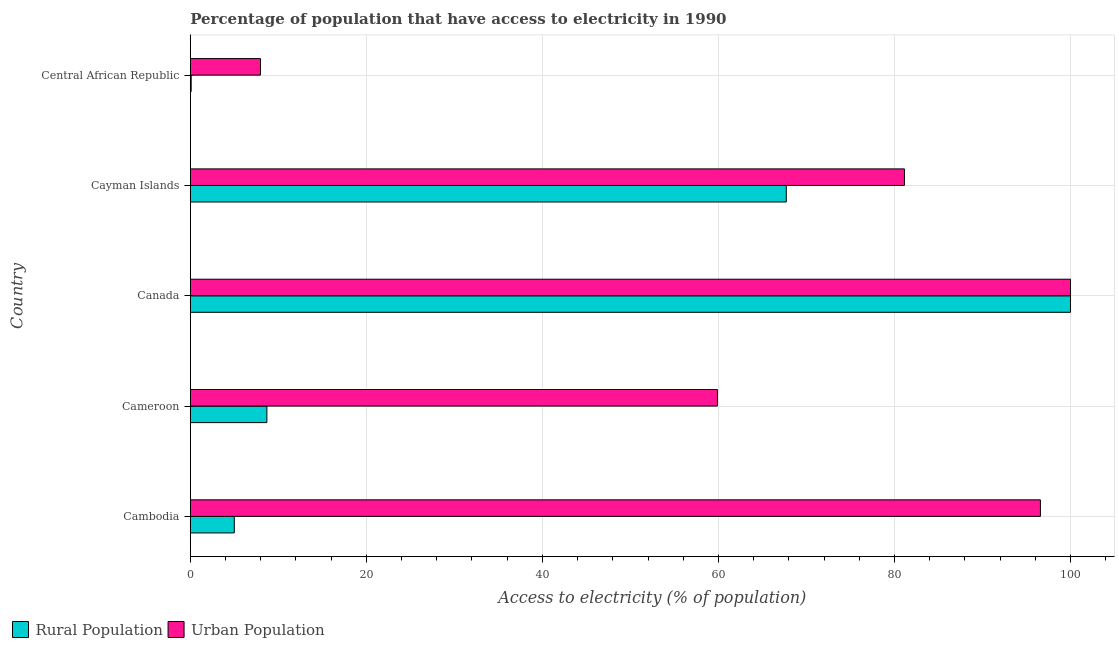Are the number of bars per tick equal to the number of legend labels?
Keep it short and to the point. Yes. How many bars are there on the 2nd tick from the bottom?
Your answer should be very brief. 2. What is the label of the 4th group of bars from the top?
Your answer should be very brief. Cameroon. In how many cases, is the number of bars for a given country not equal to the number of legend labels?
Make the answer very short. 0. What is the percentage of rural population having access to electricity in Cayman Islands?
Provide a succinct answer. 67.71. Across all countries, what is the maximum percentage of urban population having access to electricity?
Keep it short and to the point. 100. Across all countries, what is the minimum percentage of rural population having access to electricity?
Offer a very short reply. 0.1. In which country was the percentage of urban population having access to electricity maximum?
Your answer should be compact. Canada. In which country was the percentage of rural population having access to electricity minimum?
Ensure brevity in your answer.  Central African Republic. What is the total percentage of urban population having access to electricity in the graph?
Make the answer very short. 345.58. What is the difference between the percentage of rural population having access to electricity in Canada and that in Central African Republic?
Your answer should be compact. 99.9. What is the difference between the percentage of urban population having access to electricity in Cameroon and the percentage of rural population having access to electricity in Cambodia?
Make the answer very short. 54.89. What is the average percentage of rural population having access to electricity per country?
Ensure brevity in your answer.  36.3. What is the difference between the percentage of rural population having access to electricity and percentage of urban population having access to electricity in Central African Republic?
Ensure brevity in your answer.  -7.88. In how many countries, is the percentage of rural population having access to electricity greater than 8 %?
Offer a very short reply. 3. What is the ratio of the percentage of urban population having access to electricity in Cambodia to that in Cayman Islands?
Ensure brevity in your answer.  1.19. Is the percentage of urban population having access to electricity in Cambodia less than that in Cayman Islands?
Make the answer very short. No. Is the difference between the percentage of rural population having access to electricity in Cambodia and Canada greater than the difference between the percentage of urban population having access to electricity in Cambodia and Canada?
Make the answer very short. No. What is the difference between the highest and the second highest percentage of rural population having access to electricity?
Your answer should be compact. 32.29. What is the difference between the highest and the lowest percentage of urban population having access to electricity?
Your answer should be very brief. 92.02. In how many countries, is the percentage of rural population having access to electricity greater than the average percentage of rural population having access to electricity taken over all countries?
Keep it short and to the point. 2. Is the sum of the percentage of rural population having access to electricity in Cambodia and Canada greater than the maximum percentage of urban population having access to electricity across all countries?
Offer a terse response. Yes. What does the 2nd bar from the top in Cambodia represents?
Your answer should be compact. Rural Population. What does the 2nd bar from the bottom in Cayman Islands represents?
Keep it short and to the point. Urban Population. Are the values on the major ticks of X-axis written in scientific E-notation?
Your answer should be very brief. No. Does the graph contain any zero values?
Offer a very short reply. No. Does the graph contain grids?
Your answer should be very brief. Yes. How many legend labels are there?
Provide a short and direct response. 2. How are the legend labels stacked?
Provide a succinct answer. Horizontal. What is the title of the graph?
Your answer should be compact. Percentage of population that have access to electricity in 1990. What is the label or title of the X-axis?
Keep it short and to the point. Access to electricity (% of population). What is the label or title of the Y-axis?
Provide a succinct answer. Country. What is the Access to electricity (% of population) in Urban Population in Cambodia?
Your answer should be compact. 96.58. What is the Access to electricity (% of population) in Urban Population in Cameroon?
Offer a terse response. 59.89. What is the Access to electricity (% of population) of Rural Population in Canada?
Provide a succinct answer. 100. What is the Access to electricity (% of population) in Rural Population in Cayman Islands?
Ensure brevity in your answer.  67.71. What is the Access to electricity (% of population) in Urban Population in Cayman Islands?
Make the answer very short. 81.14. What is the Access to electricity (% of population) of Urban Population in Central African Republic?
Provide a short and direct response. 7.98. Across all countries, what is the maximum Access to electricity (% of population) of Rural Population?
Your answer should be compact. 100. Across all countries, what is the maximum Access to electricity (% of population) of Urban Population?
Your answer should be very brief. 100. Across all countries, what is the minimum Access to electricity (% of population) of Urban Population?
Keep it short and to the point. 7.98. What is the total Access to electricity (% of population) in Rural Population in the graph?
Ensure brevity in your answer.  181.51. What is the total Access to electricity (% of population) in Urban Population in the graph?
Give a very brief answer. 345.58. What is the difference between the Access to electricity (% of population) of Rural Population in Cambodia and that in Cameroon?
Offer a very short reply. -3.7. What is the difference between the Access to electricity (% of population) of Urban Population in Cambodia and that in Cameroon?
Provide a succinct answer. 36.7. What is the difference between the Access to electricity (% of population) in Rural Population in Cambodia and that in Canada?
Ensure brevity in your answer.  -95. What is the difference between the Access to electricity (% of population) in Urban Population in Cambodia and that in Canada?
Make the answer very short. -3.42. What is the difference between the Access to electricity (% of population) in Rural Population in Cambodia and that in Cayman Islands?
Keep it short and to the point. -62.71. What is the difference between the Access to electricity (% of population) of Urban Population in Cambodia and that in Cayman Islands?
Provide a short and direct response. 15.45. What is the difference between the Access to electricity (% of population) in Rural Population in Cambodia and that in Central African Republic?
Keep it short and to the point. 4.9. What is the difference between the Access to electricity (% of population) in Urban Population in Cambodia and that in Central African Republic?
Provide a short and direct response. 88.61. What is the difference between the Access to electricity (% of population) in Rural Population in Cameroon and that in Canada?
Provide a succinct answer. -91.3. What is the difference between the Access to electricity (% of population) in Urban Population in Cameroon and that in Canada?
Your answer should be very brief. -40.11. What is the difference between the Access to electricity (% of population) of Rural Population in Cameroon and that in Cayman Islands?
Your answer should be very brief. -59.01. What is the difference between the Access to electricity (% of population) of Urban Population in Cameroon and that in Cayman Islands?
Your response must be concise. -21.25. What is the difference between the Access to electricity (% of population) in Rural Population in Cameroon and that in Central African Republic?
Your answer should be compact. 8.6. What is the difference between the Access to electricity (% of population) of Urban Population in Cameroon and that in Central African Republic?
Ensure brevity in your answer.  51.91. What is the difference between the Access to electricity (% of population) of Rural Population in Canada and that in Cayman Islands?
Ensure brevity in your answer.  32.29. What is the difference between the Access to electricity (% of population) in Urban Population in Canada and that in Cayman Islands?
Provide a short and direct response. 18.86. What is the difference between the Access to electricity (% of population) of Rural Population in Canada and that in Central African Republic?
Give a very brief answer. 99.9. What is the difference between the Access to electricity (% of population) in Urban Population in Canada and that in Central African Republic?
Make the answer very short. 92.02. What is the difference between the Access to electricity (% of population) of Rural Population in Cayman Islands and that in Central African Republic?
Offer a terse response. 67.61. What is the difference between the Access to electricity (% of population) in Urban Population in Cayman Islands and that in Central African Republic?
Your answer should be very brief. 73.16. What is the difference between the Access to electricity (% of population) in Rural Population in Cambodia and the Access to electricity (% of population) in Urban Population in Cameroon?
Ensure brevity in your answer.  -54.89. What is the difference between the Access to electricity (% of population) in Rural Population in Cambodia and the Access to electricity (% of population) in Urban Population in Canada?
Your answer should be compact. -95. What is the difference between the Access to electricity (% of population) of Rural Population in Cambodia and the Access to electricity (% of population) of Urban Population in Cayman Islands?
Offer a very short reply. -76.14. What is the difference between the Access to electricity (% of population) of Rural Population in Cambodia and the Access to electricity (% of population) of Urban Population in Central African Republic?
Give a very brief answer. -2.98. What is the difference between the Access to electricity (% of population) of Rural Population in Cameroon and the Access to electricity (% of population) of Urban Population in Canada?
Provide a succinct answer. -91.3. What is the difference between the Access to electricity (% of population) in Rural Population in Cameroon and the Access to electricity (% of population) in Urban Population in Cayman Islands?
Provide a succinct answer. -72.44. What is the difference between the Access to electricity (% of population) in Rural Population in Cameroon and the Access to electricity (% of population) in Urban Population in Central African Republic?
Provide a short and direct response. 0.72. What is the difference between the Access to electricity (% of population) of Rural Population in Canada and the Access to electricity (% of population) of Urban Population in Cayman Islands?
Provide a short and direct response. 18.86. What is the difference between the Access to electricity (% of population) of Rural Population in Canada and the Access to electricity (% of population) of Urban Population in Central African Republic?
Offer a very short reply. 92.02. What is the difference between the Access to electricity (% of population) in Rural Population in Cayman Islands and the Access to electricity (% of population) in Urban Population in Central African Republic?
Provide a succinct answer. 59.74. What is the average Access to electricity (% of population) in Rural Population per country?
Offer a terse response. 36.3. What is the average Access to electricity (% of population) in Urban Population per country?
Provide a short and direct response. 69.12. What is the difference between the Access to electricity (% of population) in Rural Population and Access to electricity (% of population) in Urban Population in Cambodia?
Offer a very short reply. -91.58. What is the difference between the Access to electricity (% of population) in Rural Population and Access to electricity (% of population) in Urban Population in Cameroon?
Give a very brief answer. -51.19. What is the difference between the Access to electricity (% of population) of Rural Population and Access to electricity (% of population) of Urban Population in Cayman Islands?
Make the answer very short. -13.42. What is the difference between the Access to electricity (% of population) of Rural Population and Access to electricity (% of population) of Urban Population in Central African Republic?
Your answer should be very brief. -7.88. What is the ratio of the Access to electricity (% of population) of Rural Population in Cambodia to that in Cameroon?
Your response must be concise. 0.57. What is the ratio of the Access to electricity (% of population) in Urban Population in Cambodia to that in Cameroon?
Keep it short and to the point. 1.61. What is the ratio of the Access to electricity (% of population) in Urban Population in Cambodia to that in Canada?
Make the answer very short. 0.97. What is the ratio of the Access to electricity (% of population) of Rural Population in Cambodia to that in Cayman Islands?
Your response must be concise. 0.07. What is the ratio of the Access to electricity (% of population) of Urban Population in Cambodia to that in Cayman Islands?
Your answer should be compact. 1.19. What is the ratio of the Access to electricity (% of population) of Rural Population in Cambodia to that in Central African Republic?
Provide a succinct answer. 50. What is the ratio of the Access to electricity (% of population) of Urban Population in Cambodia to that in Central African Republic?
Make the answer very short. 12.11. What is the ratio of the Access to electricity (% of population) in Rural Population in Cameroon to that in Canada?
Give a very brief answer. 0.09. What is the ratio of the Access to electricity (% of population) of Urban Population in Cameroon to that in Canada?
Provide a short and direct response. 0.6. What is the ratio of the Access to electricity (% of population) in Rural Population in Cameroon to that in Cayman Islands?
Your answer should be compact. 0.13. What is the ratio of the Access to electricity (% of population) of Urban Population in Cameroon to that in Cayman Islands?
Ensure brevity in your answer.  0.74. What is the ratio of the Access to electricity (% of population) in Rural Population in Cameroon to that in Central African Republic?
Offer a very short reply. 87. What is the ratio of the Access to electricity (% of population) of Urban Population in Cameroon to that in Central African Republic?
Your answer should be compact. 7.51. What is the ratio of the Access to electricity (% of population) of Rural Population in Canada to that in Cayman Islands?
Your answer should be very brief. 1.48. What is the ratio of the Access to electricity (% of population) of Urban Population in Canada to that in Cayman Islands?
Provide a short and direct response. 1.23. What is the ratio of the Access to electricity (% of population) of Rural Population in Canada to that in Central African Republic?
Ensure brevity in your answer.  1000. What is the ratio of the Access to electricity (% of population) of Urban Population in Canada to that in Central African Republic?
Your response must be concise. 12.54. What is the ratio of the Access to electricity (% of population) in Rural Population in Cayman Islands to that in Central African Republic?
Offer a very short reply. 677.11. What is the ratio of the Access to electricity (% of population) of Urban Population in Cayman Islands to that in Central African Republic?
Provide a succinct answer. 10.17. What is the difference between the highest and the second highest Access to electricity (% of population) of Rural Population?
Make the answer very short. 32.29. What is the difference between the highest and the second highest Access to electricity (% of population) of Urban Population?
Offer a terse response. 3.42. What is the difference between the highest and the lowest Access to electricity (% of population) of Rural Population?
Ensure brevity in your answer.  99.9. What is the difference between the highest and the lowest Access to electricity (% of population) of Urban Population?
Ensure brevity in your answer.  92.02. 